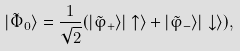Convert formula to latex. <formula><loc_0><loc_0><loc_500><loc_500>| \tilde { \Phi } _ { 0 } \rangle = \frac { 1 } { \sqrt { 2 } } ( | \tilde { \varphi } _ { + } \rangle | \uparrow \rangle + | \tilde { \varphi } _ { - } \rangle | \downarrow \rangle ) ,</formula> 